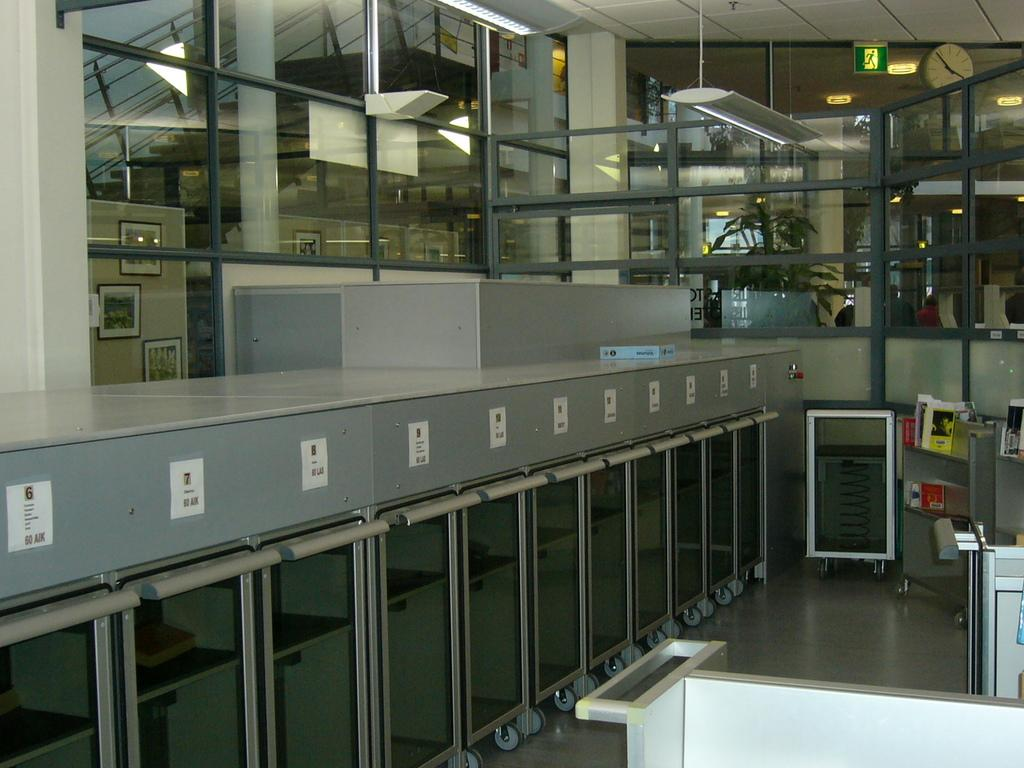What type of furniture can be seen in the image? There are desks in the image. What type of lighting is present in the image? Electrical lights are visible in the image. What type of object might be used for vision correction? Glasses are present in the image. What type of signage is visible in the image? There is a sign board in the image. What type of architectural feature allows for vertical movement between floors? A staircase is visible in the image. What type of equipment is used for various industrial processes? Machinery is present in the image. What type of safety feature is present near the staircase? The railing is in the image. What type of timekeeping device is visible in the image? There is: There is a clock in the image. Where is the clock located in the image? The clock is attached to a wall. How many sheep are visible on the desks in the image? There are no sheep present in the image. What type of balance is required to climb the staircase in the image? The staircase in the image does not require any specific balance; it is a standard staircase. How many screws are visible on the machinery in the image? The number of screws on the machinery in the image cannot be determined from the image alone. 